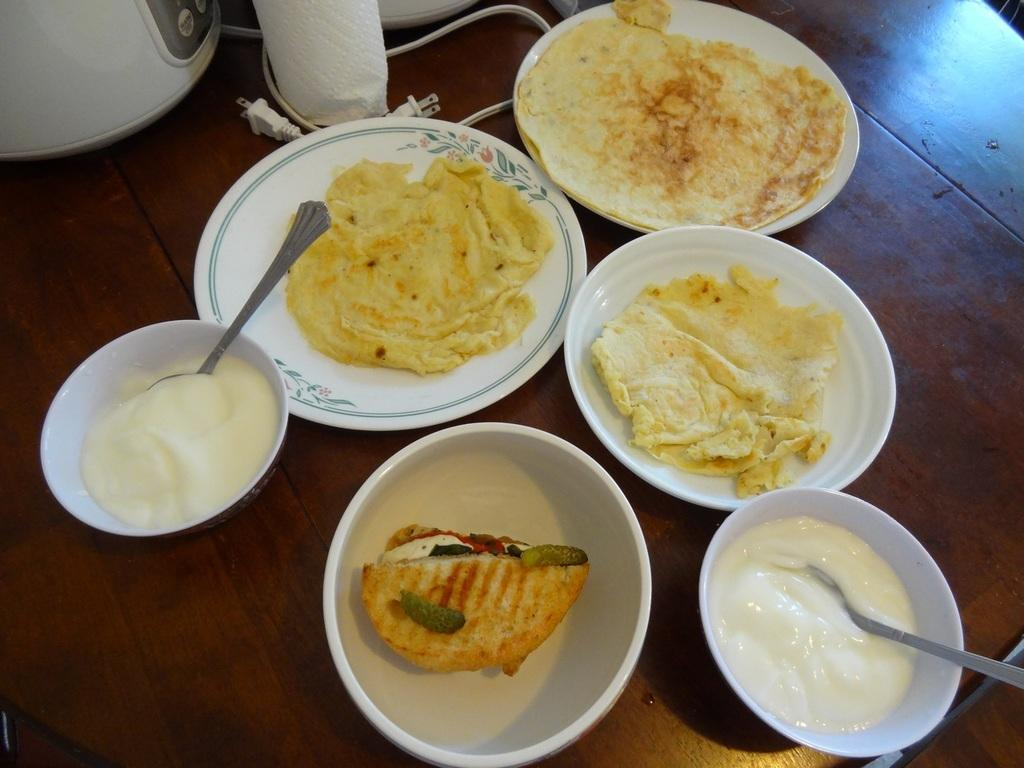What type of dishware can be seen in the image? There are plates and bowls in the image. What is present on the plates and bowls? There is food in the image. Can you describe any other visible objects in the image? There is a cable visible in the image, and there are other objects on the table. What type of owl can be seen perched on the cable in the image? There is no owl present in the image; the cable is the only object mentioned in the facts. 